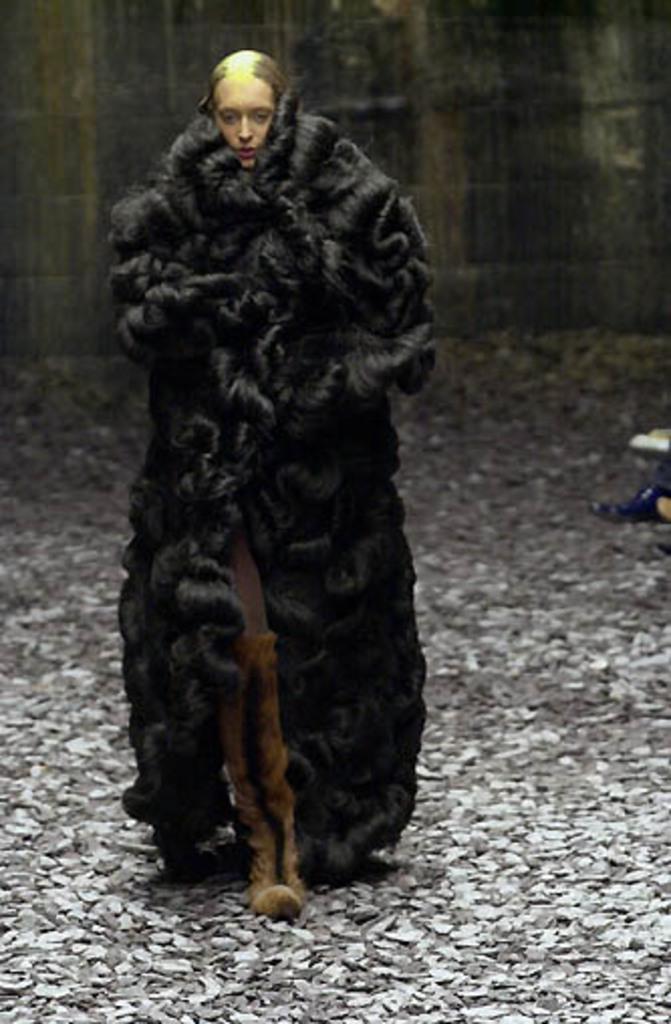Describe this image in one or two sentences. In this image there is a woman walking, there are stones on the ground, there is a person's leg towards the right of the image, at the background of the image there is a wall. 